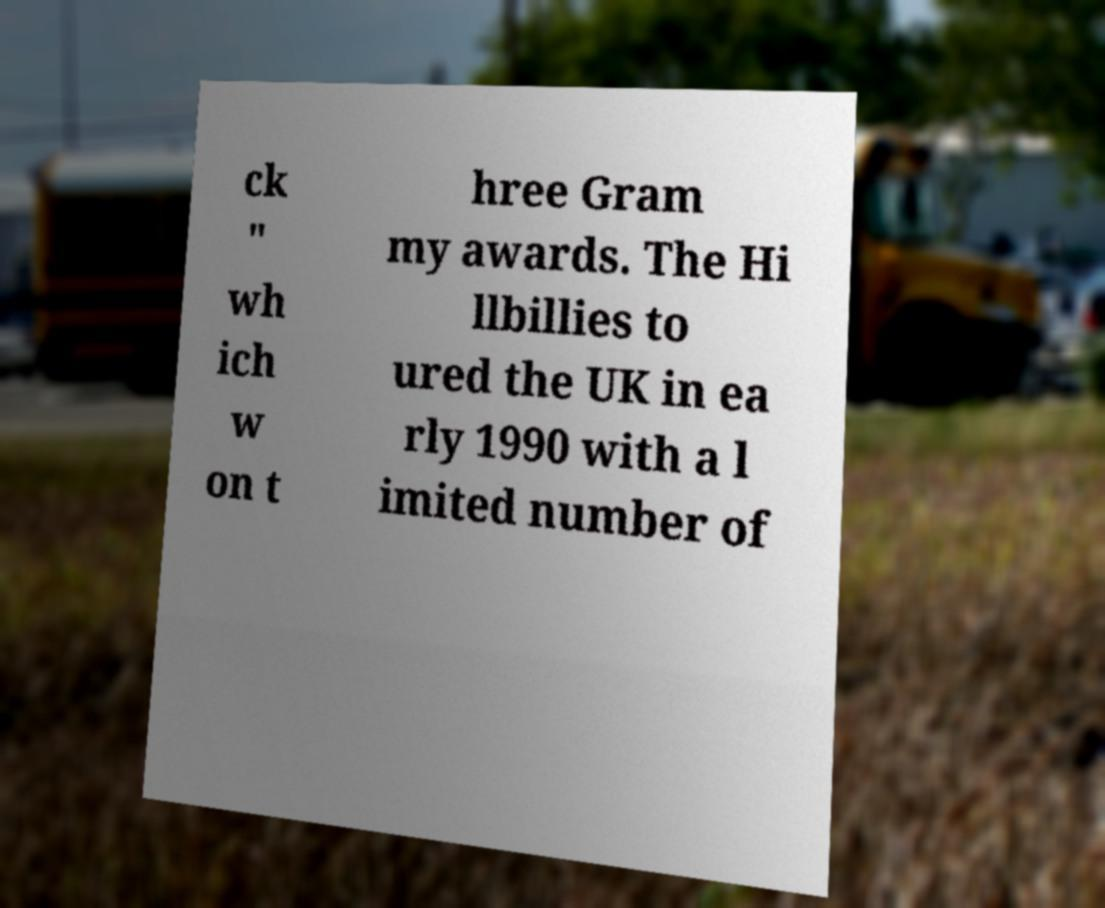Can you read and provide the text displayed in the image?This photo seems to have some interesting text. Can you extract and type it out for me? ck " wh ich w on t hree Gram my awards. The Hi llbillies to ured the UK in ea rly 1990 with a l imited number of 